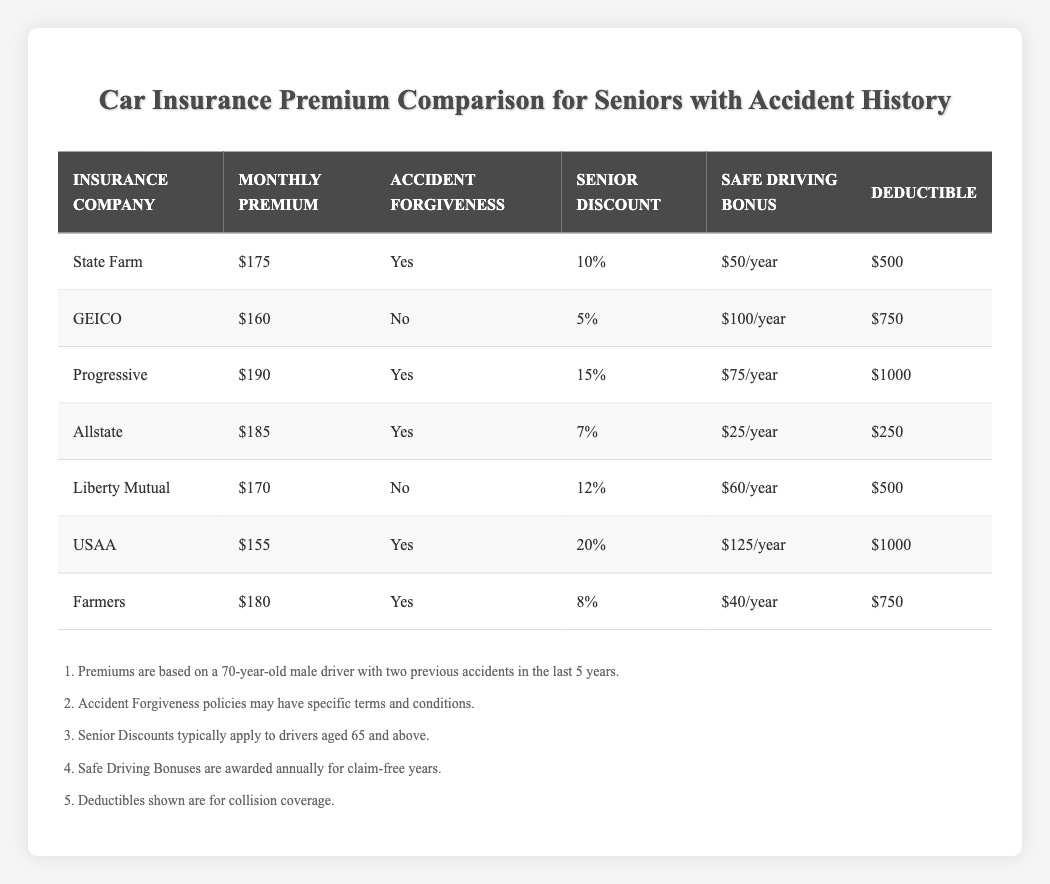What is the monthly premium for USAA? Referring to the table, the Monthly Premium column for USAA shows $155.
Answer: $155 Which insurance company offers the highest senior discount? Looking at the Senior Discount column, USAA offers a 20% discount, which is higher than any other insurance company's discount listed.
Answer: USAA Is Accident Forgiveness available with GEICO? By checking the Accident Forgiveness column for GEICO, it is marked as "No", indicating that they do not offer Accident Forgiveness.
Answer: No What is the difference between the monthly premium of State Farm and Liberty Mutual? State Farm's premium is $175 and Liberty Mutual's premium is $170. The difference is calculated as $175 - $170 = $5.
Answer: $5 What is the average deductible among the insurance companies that offer Accident Forgiveness? The deductible values for companies offering Accident Forgiveness are $500 (State Farm), $1000 (Progressive), $250 (Allstate), $1000 (USAA), and $750 (Farmers). The total sum is $500 + $1000 + $250 + $1000 + $750 = $3500. There are 5 data points, so the average deductible is $3500 / 5 = $700.
Answer: $700 Which insurance company has the lowest monthly premium? Upon reviewing the Monthly Premium column, USAA has the lowest premium at $155 compared to the others in the table.
Answer: USAA How much bonus is offered by Liberty Mutual for safe driving? Checking the Safe Driving Bonus column for Liberty Mutual indicates it offers a $60 per year bonus for safe driving.
Answer: $60 What are the conditions under which State Farm provides Accident Forgiveness? The table states that Accident Forgiveness policies may have specific terms and conditions, but does not provide details. Therefore, we cannot determine the exact conditions from the table alone.
Answer: Not specified in the table Which company has a higher premium, Progressive or Farmers? Looking at the Monthly Premium column, Progressive charges $190, while Farmers charges $180. Since $190 is greater than $180, Progressive has the higher premium.
Answer: Progressive 